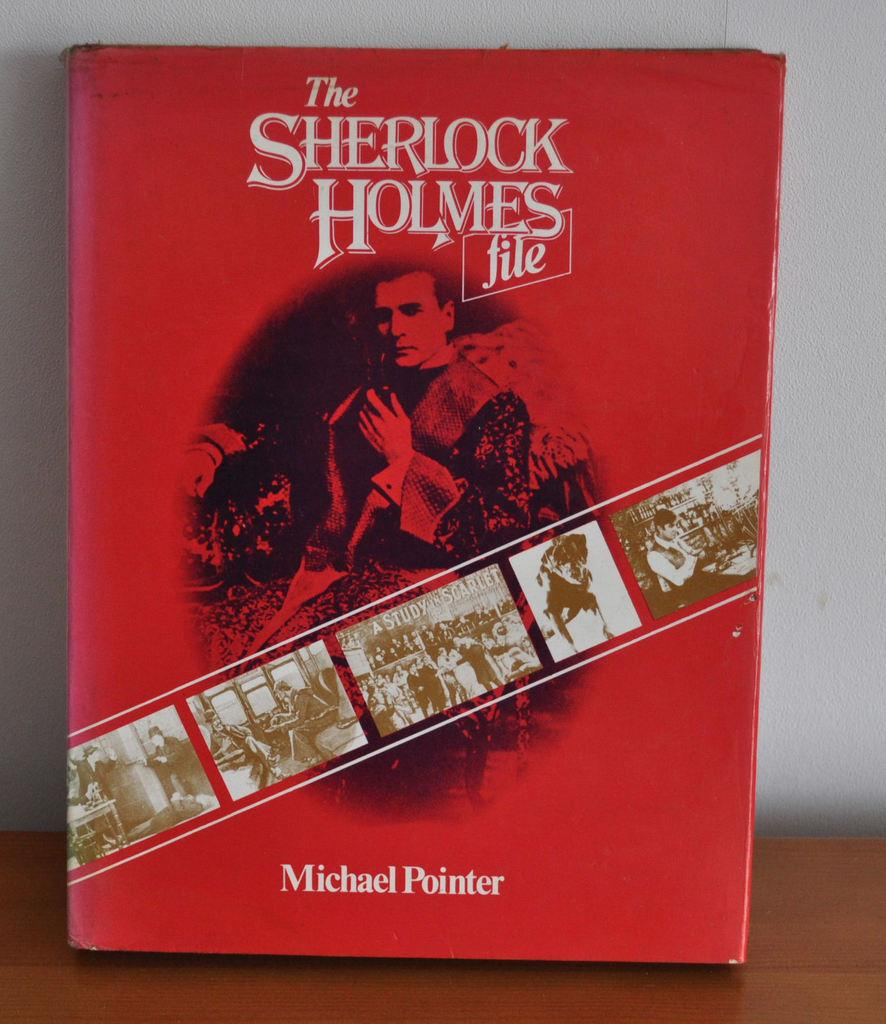<image>
Summarize the visual content of the image. a book that is titled ' the sherlock holmes file' on it 